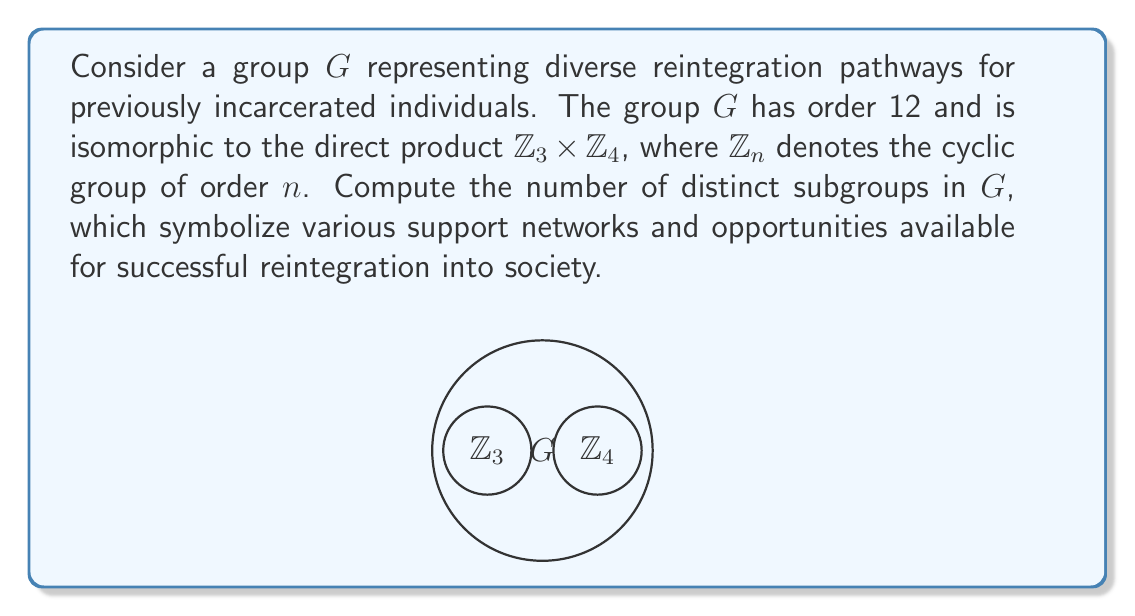Show me your answer to this math problem. To find the number of distinct subgroups in $G \cong \mathbb{Z}_3 \times \mathbb{Z}_4$, we follow these steps:

1) First, recall that the subgroups of a direct product are determined by the subgroups of its factors.

2) For $\mathbb{Z}_3$:
   - It has 2 subgroups: $\{0\}$ and $\mathbb{Z}_3$ itself.

3) For $\mathbb{Z}_4$:
   - It has 3 subgroups: $\{0\}$, $\{0,2\}$, and $\mathbb{Z}_4$ itself.

4) Now, we use the formula for the number of subgroups in a direct product:
   If $H_1, H_2, ..., H_n$ are the subgroups of $G_1, G_2, ..., G_n$ respectively, then the subgroups of $G_1 \times G_2 \times ... \times G_n$ are of the form $H_1 \times H_2 \times ... \times H_n$.

5) Therefore, the number of subgroups in $G$ is the product of the number of subgroups in $\mathbb{Z}_3$ and $\mathbb{Z}_4$:

   $2 \times 3 = 6$

This means there are 6 distinct subgroups in $G$, representing different combinations of support networks and opportunities for reintegration.
Answer: 6 